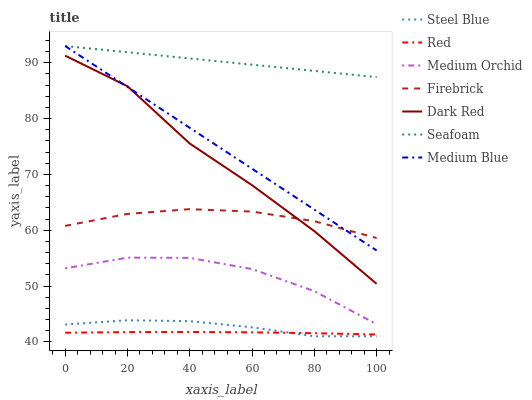Does Red have the minimum area under the curve?
Answer yes or no. Yes. Does Seafoam have the maximum area under the curve?
Answer yes or no. Yes. Does Firebrick have the minimum area under the curve?
Answer yes or no. No. Does Firebrick have the maximum area under the curve?
Answer yes or no. No. Is Seafoam the smoothest?
Answer yes or no. Yes. Is Dark Red the roughest?
Answer yes or no. Yes. Is Firebrick the smoothest?
Answer yes or no. No. Is Firebrick the roughest?
Answer yes or no. No. Does Firebrick have the lowest value?
Answer yes or no. No. Does Seafoam have the highest value?
Answer yes or no. Yes. Does Firebrick have the highest value?
Answer yes or no. No. Is Medium Orchid less than Firebrick?
Answer yes or no. Yes. Is Medium Blue greater than Red?
Answer yes or no. Yes. Does Medium Blue intersect Dark Red?
Answer yes or no. Yes. Is Medium Blue less than Dark Red?
Answer yes or no. No. Is Medium Blue greater than Dark Red?
Answer yes or no. No. Does Medium Orchid intersect Firebrick?
Answer yes or no. No. 